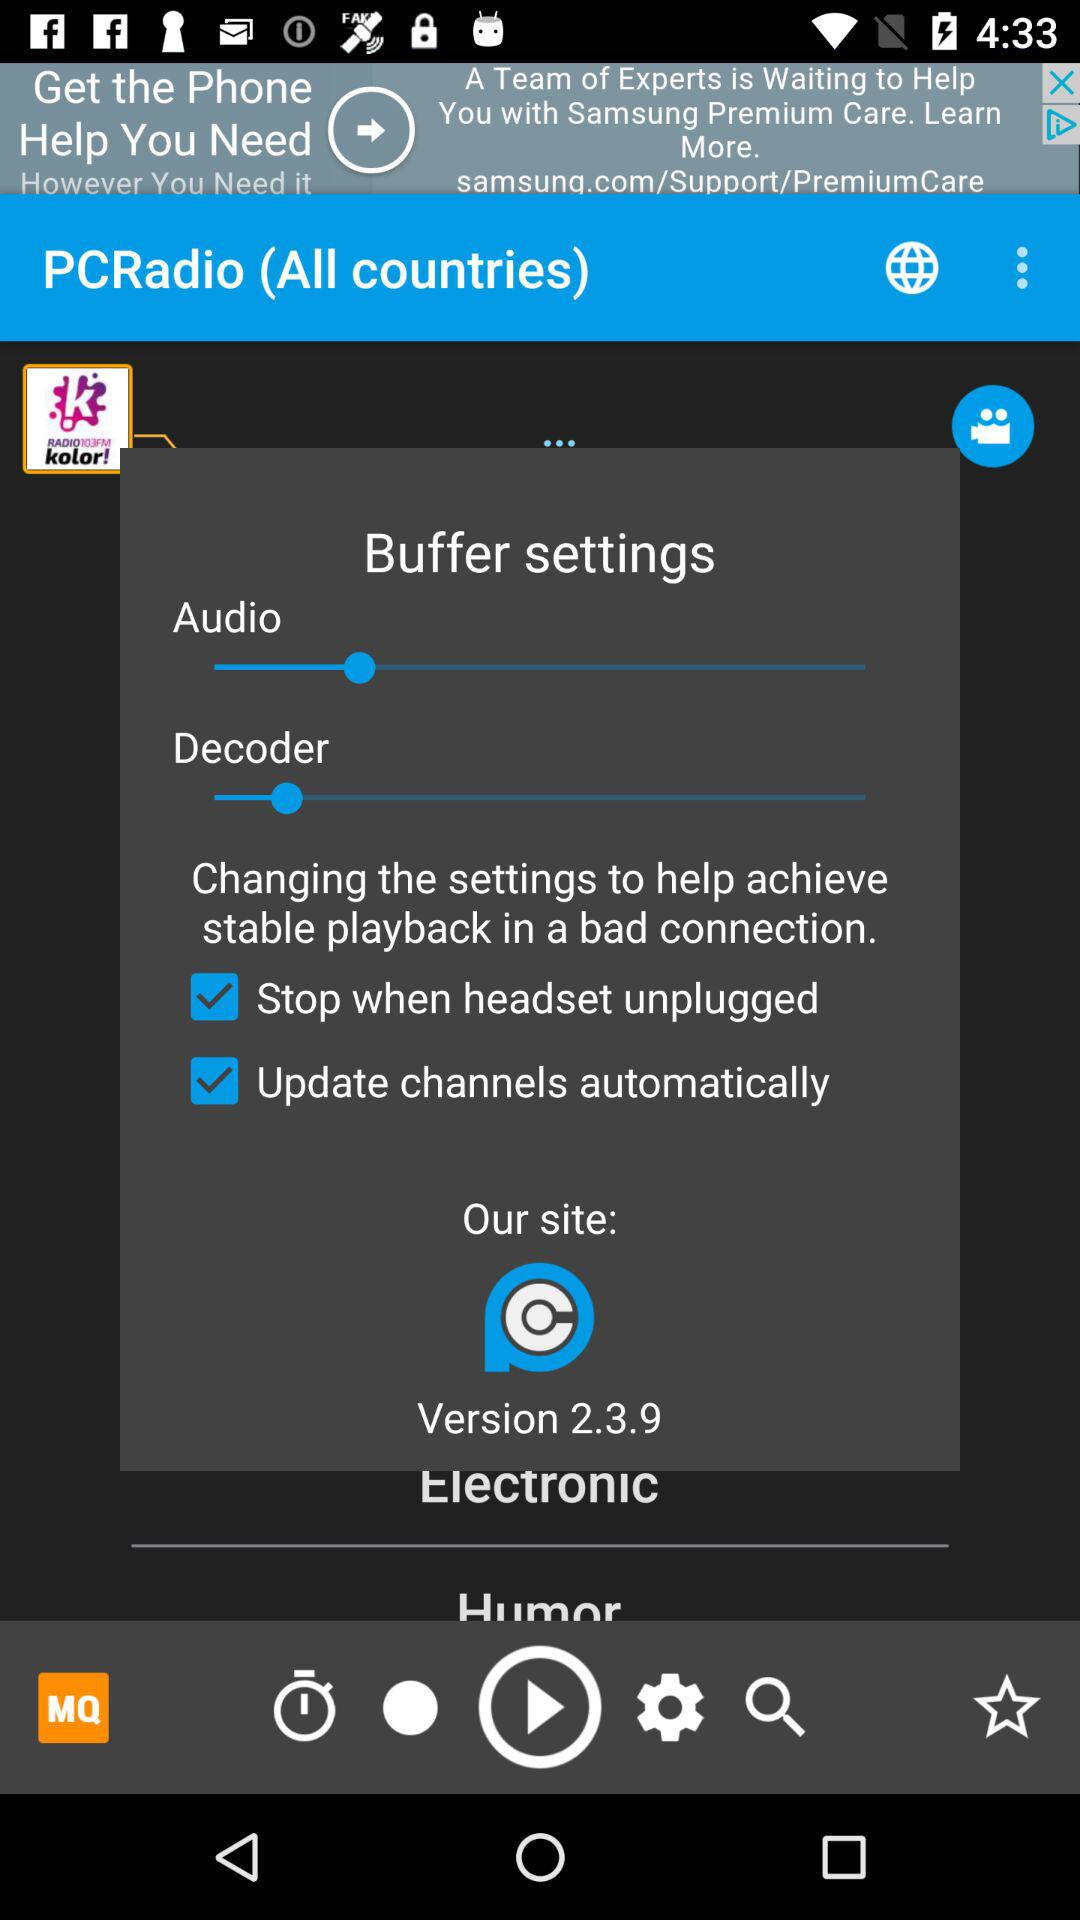What is the app name? The app name is "PCRadio". 